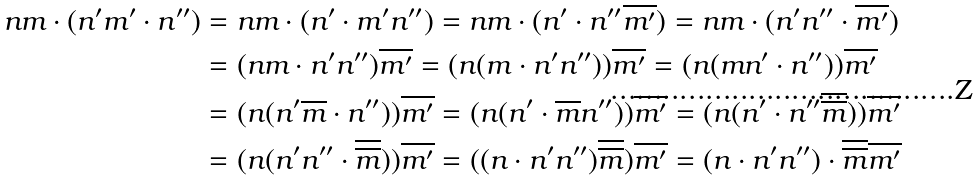Convert formula to latex. <formula><loc_0><loc_0><loc_500><loc_500>n m \cdot ( n ^ { \prime } m ^ { \prime } \cdot n ^ { \prime \prime } ) & = n m \cdot ( n ^ { \prime } \cdot m ^ { \prime } n ^ { \prime \prime } ) = n m \cdot ( n ^ { \prime } \cdot n ^ { \prime \prime } \overline { m ^ { \prime } } ) = n m \cdot ( n ^ { \prime } n ^ { \prime \prime } \cdot \overline { m ^ { \prime } } ) \\ & = ( n m \cdot n ^ { \prime } n ^ { \prime \prime } ) \overline { m ^ { \prime } } = ( n ( m \cdot n ^ { \prime } n ^ { \prime \prime } ) ) \overline { m ^ { \prime } } = ( n ( m n ^ { \prime } \cdot n ^ { \prime \prime } ) ) \overline { m ^ { \prime } } \\ & = ( n ( n ^ { \prime } \overline { m } \cdot n ^ { \prime \prime } ) ) \overline { m ^ { \prime } } = ( n ( n ^ { \prime } \cdot \overline { m } n ^ { \prime \prime } ) ) \overline { m ^ { \prime } } = ( n ( n ^ { \prime } \cdot n ^ { \prime \prime } \overline { \overline { m } } ) ) \overline { m ^ { \prime } } \\ & = ( n ( n ^ { \prime } n ^ { \prime \prime } \cdot \overline { \overline { m } } ) ) \overline { m ^ { \prime } } = ( ( n \cdot n ^ { \prime } n ^ { \prime \prime } ) \overline { \overline { m } } ) \overline { m ^ { \prime } } = ( n \cdot n ^ { \prime } n ^ { \prime \prime } ) \cdot \overline { \overline { m } } \overline { m ^ { \prime } }</formula> 